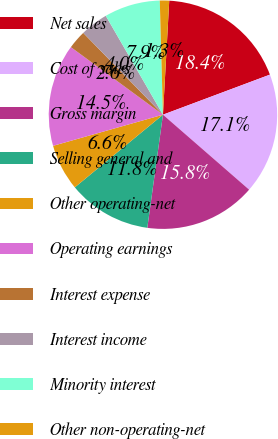Convert chart to OTSL. <chart><loc_0><loc_0><loc_500><loc_500><pie_chart><fcel>Net sales<fcel>Cost of sales<fcel>Gross margin<fcel>Selling general and<fcel>Other operating-net<fcel>Operating earnings<fcel>Interest expense<fcel>Interest income<fcel>Minority interest<fcel>Other non-operating-net<nl><fcel>18.42%<fcel>17.1%<fcel>15.79%<fcel>11.84%<fcel>6.58%<fcel>14.47%<fcel>2.63%<fcel>3.95%<fcel>7.9%<fcel>1.32%<nl></chart> 